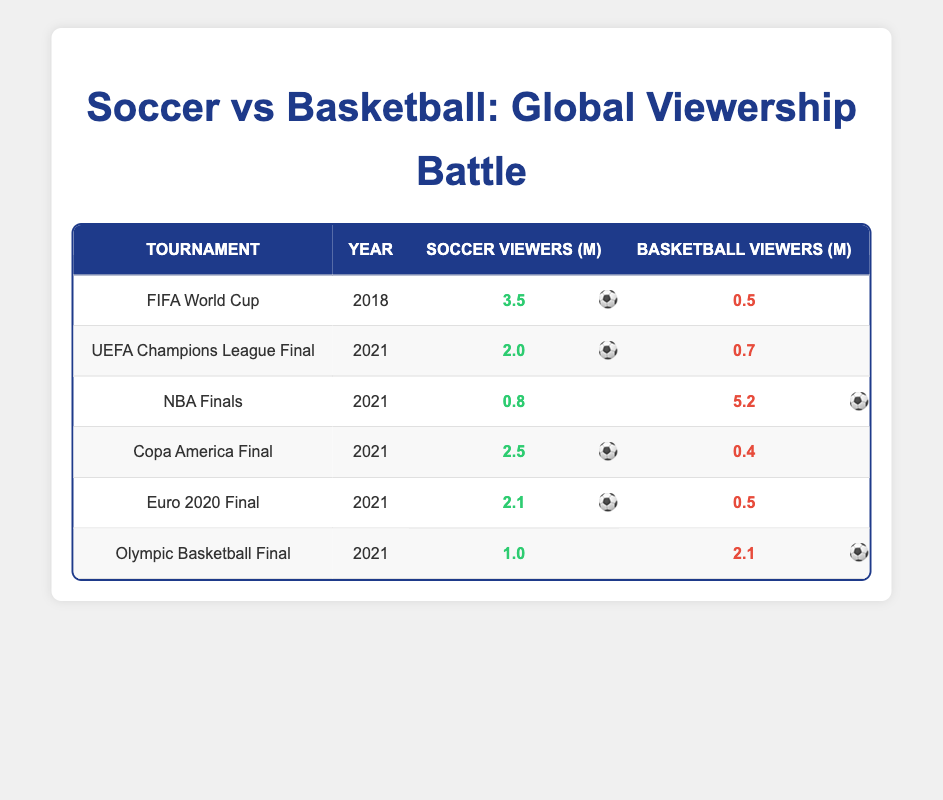What was the global viewership for the FIFA World Cup in 2018? According to the table, the FIFA World Cup in 2018 had 3.5 million viewers for soccer and 0.5 million viewers for basketball.
Answer: 3.5 million Which tournament had the highest soccer viewership in 2021? Looking at the soccer viewers for the 2021 tournaments, the Copa America Final had 2.5 million, UEFA Champions League Final had 2.0 million, Euro 2020 Final had 2.1 million, and the NBA Finals had only 0.8 million. Therefore, the Copa America Final had the highest soccer viewership at 2.5 million.
Answer: Copa America Final What is the total soccer viewership across all the tournaments listed? To find the total soccer viewership, we add the soccer viewers from all tournaments: 3.5 (FIFA World Cup) + 2.0 (UEFA Champions League Final) + 0.8 (NBA Finals) + 2.5 (Copa America Final) + 2.1 (Euro 2020 Final) + 1.0 (Olympic Basketball Final) = 12.9 million.
Answer: 12.9 million Did the UEFA Champions League Final have more viewers than the Olympic Basketball Final? The UEFA Champions League Final had 2.0 million viewers for soccer while the Olympic Basketball Final had only 1.0 million viewers for soccer. Therefore, yes, the UEFA Champions League Final had more viewers than the Olympic Basketball Final.
Answer: Yes What was the total viewership for basketball during the NBA Finals? The table shows that during the NBA Finals in 2021, there were 5.2 million viewers for basketball.
Answer: 5.2 million Is it true that soccer viewership exceeded basketball viewership in all tournaments listed? By examining the data, the soccer viewership exceeds basketball viewership in the FIFA World Cup, UEFA Champions League Final, Copa America Final, and Euro 2020 Final. The only exceptions are the NBA Finals and the Olympic Basketball Final where basketball viewership was higher. Thus, this statement is false.
Answer: No Which tournament had a closer viewership between soccer and basketball, based on the data provided? By examining the data, the tournaments with closer viewership are the UEFA Champions League Final (soccer 2.0 million, basketball 0.7 million) and the Olympic Basketball Final (soccer 1.0 million, basketball 2.1 million). The absolute viewership difference is the smallest in the UEFA Champions League Final at 1.3 million.
Answer: UEFA Champions League Final Among the tournaments listed in 2021, how many had more soccer viewers than basketball viewers? The tournaments in 2021 where soccer viewership was greater than basketball viewership are the UEFA Champions League Final (2.0 vs. 0.7), the Copa America Final (2.5 vs. 0.4), and the Euro 2020 Final (2.1 vs. 0.5). Therefore, there are 3 tournaments.
Answer: 3 